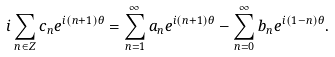Convert formula to latex. <formula><loc_0><loc_0><loc_500><loc_500>i \sum _ { n \in Z } c _ { n } e ^ { i ( n + 1 ) \theta } = \sum _ { n = 1 } ^ { \infty } a _ { n } e ^ { i ( n + 1 ) \theta } - \sum _ { n = 0 } ^ { \infty } b _ { n } e ^ { i ( 1 - n ) \theta } .</formula> 